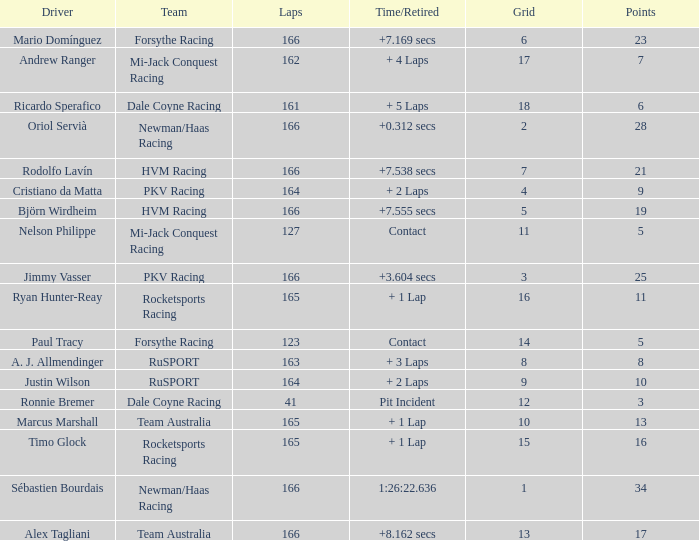Help me parse the entirety of this table. {'header': ['Driver', 'Team', 'Laps', 'Time/Retired', 'Grid', 'Points'], 'rows': [['Mario Domínguez', 'Forsythe Racing', '166', '+7.169 secs', '6', '23'], ['Andrew Ranger', 'Mi-Jack Conquest Racing', '162', '+ 4 Laps', '17', '7'], ['Ricardo Sperafico', 'Dale Coyne Racing', '161', '+ 5 Laps', '18', '6'], ['Oriol Servià', 'Newman/Haas Racing', '166', '+0.312 secs', '2', '28'], ['Rodolfo Lavín', 'HVM Racing', '166', '+7.538 secs', '7', '21'], ['Cristiano da Matta', 'PKV Racing', '164', '+ 2 Laps', '4', '9'], ['Björn Wirdheim', 'HVM Racing', '166', '+7.555 secs', '5', '19'], ['Nelson Philippe', 'Mi-Jack Conquest Racing', '127', 'Contact', '11', '5'], ['Jimmy Vasser', 'PKV Racing', '166', '+3.604 secs', '3', '25'], ['Ryan Hunter-Reay', 'Rocketsports Racing', '165', '+ 1 Lap', '16', '11'], ['Paul Tracy', 'Forsythe Racing', '123', 'Contact', '14', '5'], ['A. J. Allmendinger', 'RuSPORT', '163', '+ 3 Laps', '8', '8'], ['Justin Wilson', 'RuSPORT', '164', '+ 2 Laps', '9', '10'], ['Ronnie Bremer', 'Dale Coyne Racing', '41', 'Pit Incident', '12', '3'], ['Marcus Marshall', 'Team Australia', '165', '+ 1 Lap', '10', '13'], ['Timo Glock', 'Rocketsports Racing', '165', '+ 1 Lap', '15', '16'], ['Sébastien Bourdais', 'Newman/Haas Racing', '166', '1:26:22.636', '1', '34'], ['Alex Tagliani', 'Team Australia', '166', '+8.162 secs', '13', '17']]} Driver Ricardo Sperafico has what as his average laps? 161.0. 